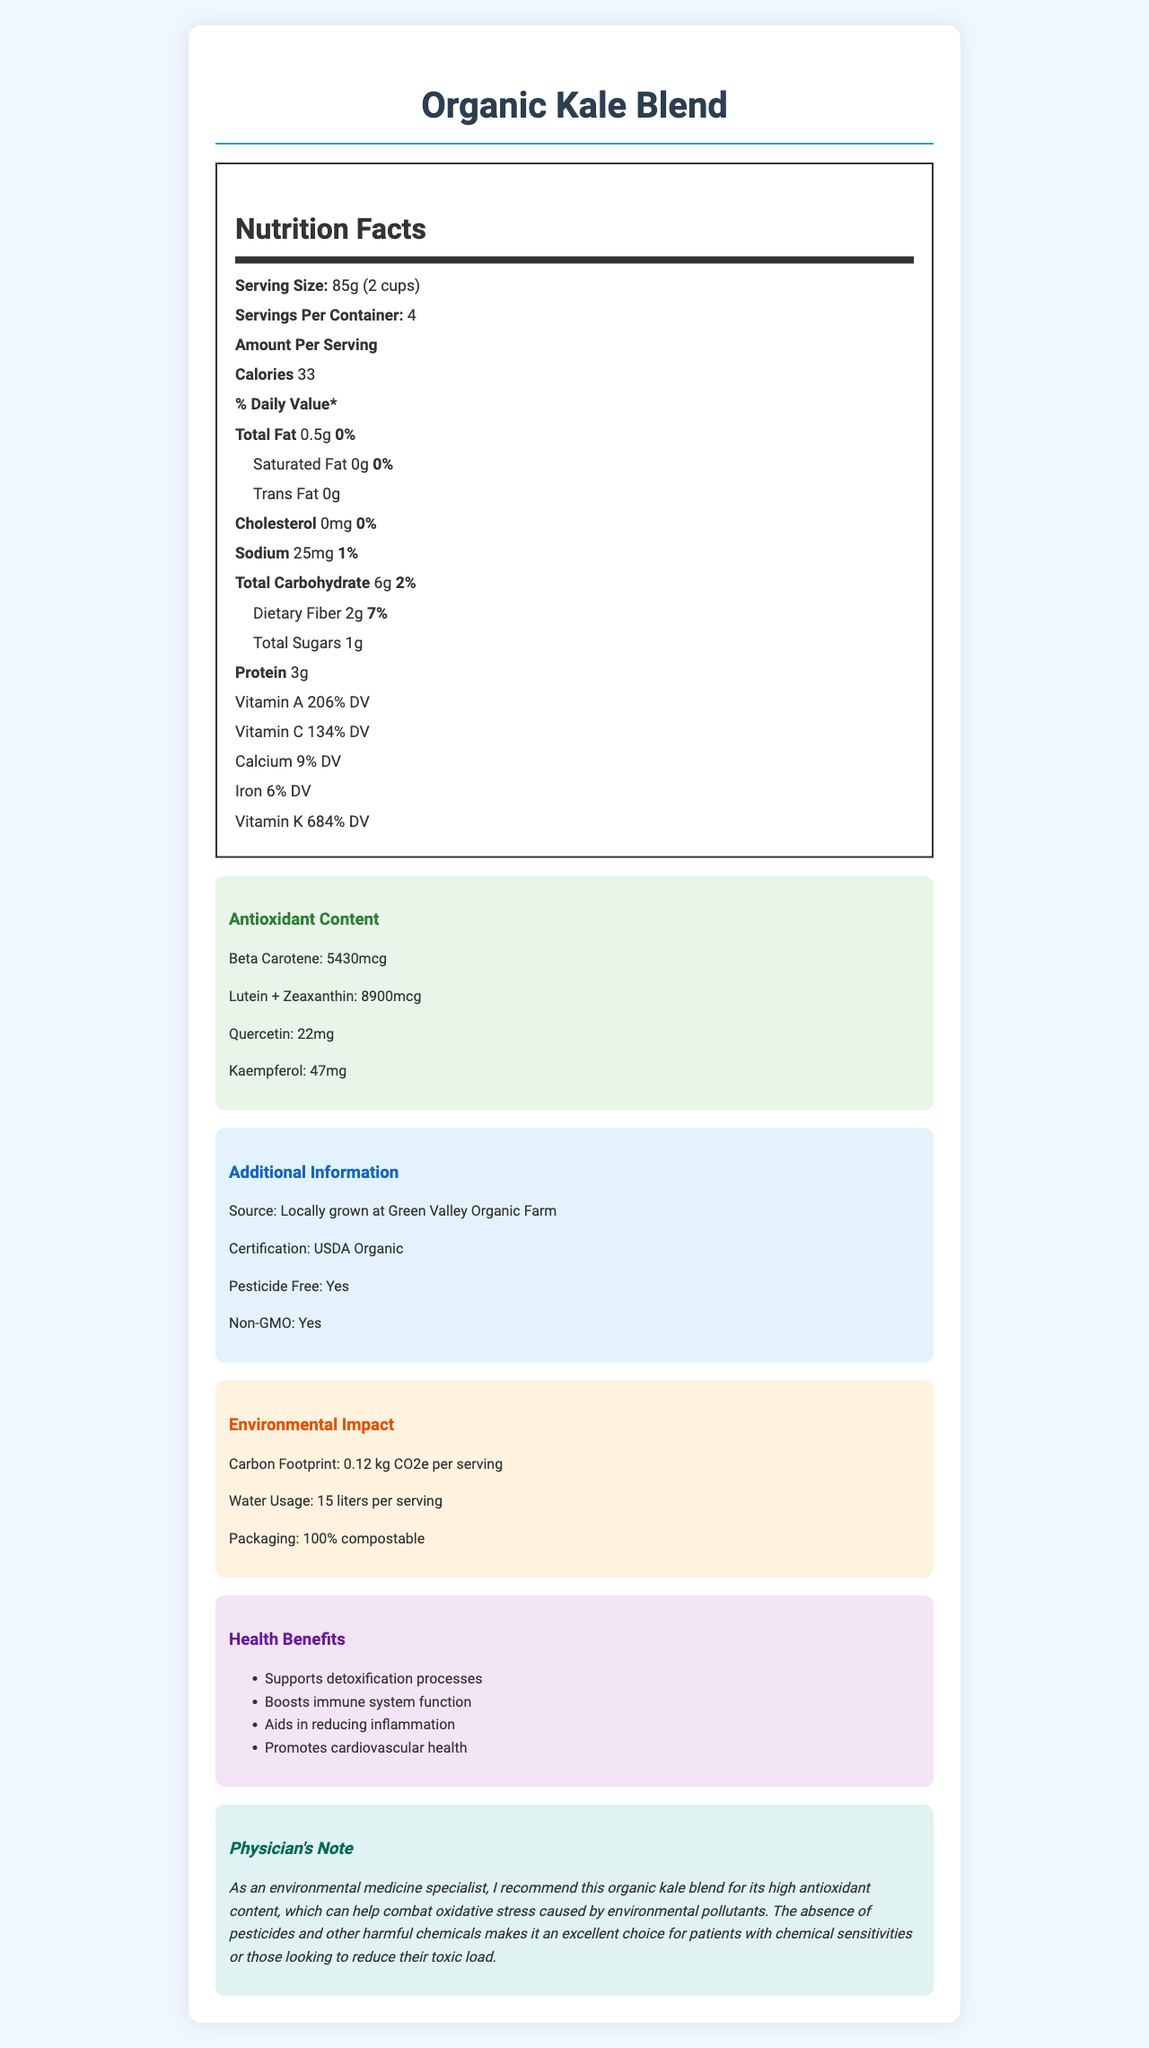what is the serving size for the Organic Kale Blend? The serving size is listed as "85g (2 cups)" in the Nutrition Facts section.
Answer: 85g (2 cups) how many calories are there per serving of the Organic Kale Blend? The document states that there are 33 calories per serving.
Answer: 33 calories what is the percentage of the Daily Value for Vitamin A per serving? The document states that Vitamin A provides 206% of the Daily Value per serving.
Answer: 206% DV how much sodium is in one serving of the Organic Kale Blend? The sodium content per serving is listed as 25mg.
Answer: 25mg name two antioxidants found in the Organic Kale Blend. The Antioxidant Content section lists Beta Carotene and Lutein + Zeaxanthin as antioxidants present in the kale blend.
Answer: Beta Carotene, Lutein + Zeaxanthin what is the carbon footprint per serving of this product? The Environmental Impact section mentions a carbon footprint of 0.12 kg CO2e per serving.
Answer: 0.12 kg CO2e identify one health benefit mentioned for the Organic Kale Blend. The Health Benefits section lists "Supports detoxification processes" as one of the benefits.
Answer: Supports detoxification processes how many grams of protein are in a serving? A. 2g B. 4g C. 3g D. 1g The protein content per serving is listed as 3g.
Answer: C which of the following certifications does the Organic Kale Blend have? I. USDA Organic II. Non-GMO Project Verified III. Fair Trade Certified The document specifies that the product has USDA Organic certification. There's no mention of Non-GMO Project Verified or Fair Trade Certified.
Answer: I is the packaging of the Organic Kale Blend compostable? Yes/No The Environmental Impact section states that the packaging is 100% compostable.
Answer: Yes summarize the main idea of the document. The document serves as a comprehensive guide to the nutritional and environmental benefits of the Organic Kale Blend, detailing its high antioxidant content, lack of harmful chemicals, and various health benefits. It also emphasizes its local sourcing and low environmental footprint.
Answer: The document provides detailed nutritional information about the Organic Kale Blend, highlighting its various vitamins, antioxidants, and health benefits. It also touches on the product's environmental impact, certifications, and why it is recommended by a physician specializing in environmental medicine. what farming techniques are used for the Organic Kale Blend? The document does not provide specific details on the farming techniques used for this product.
Answer: I don't know 